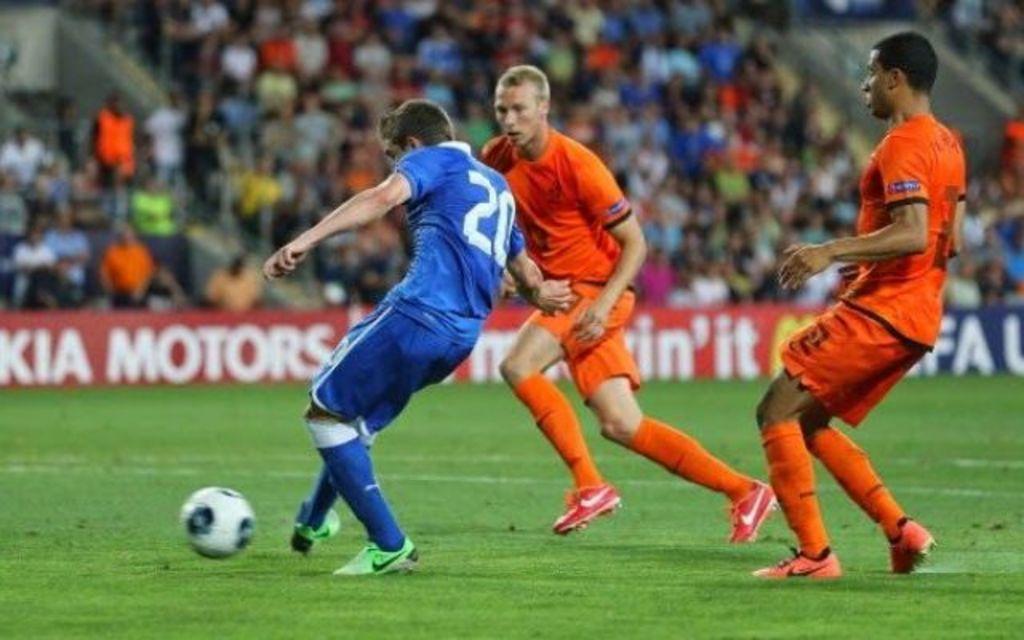Could you give a brief overview of what you see in this image? In this image, we can see three persons are playing a game with a ball on the grass. Background there is a blur view. Here we can see banners and people. 